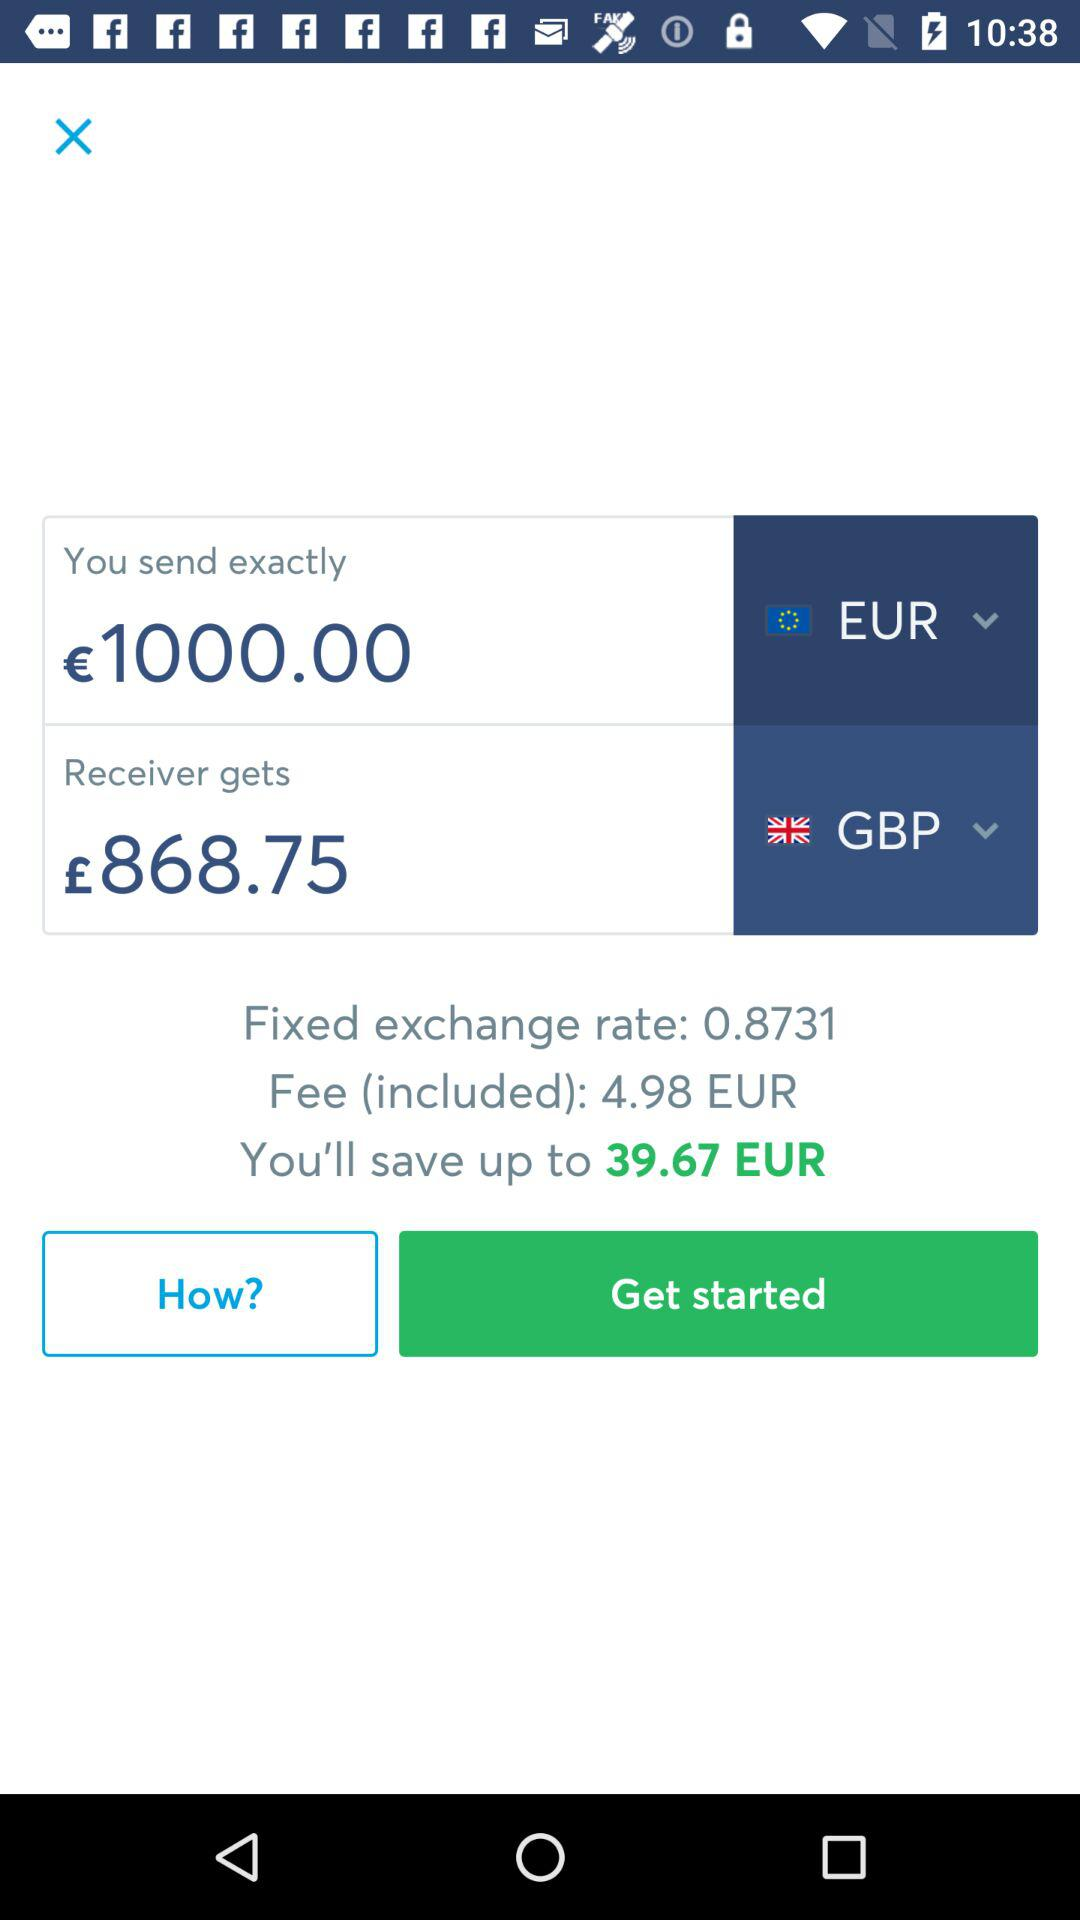How much is the conversion rate?
Answer the question using a single word or phrase. 0.8731 